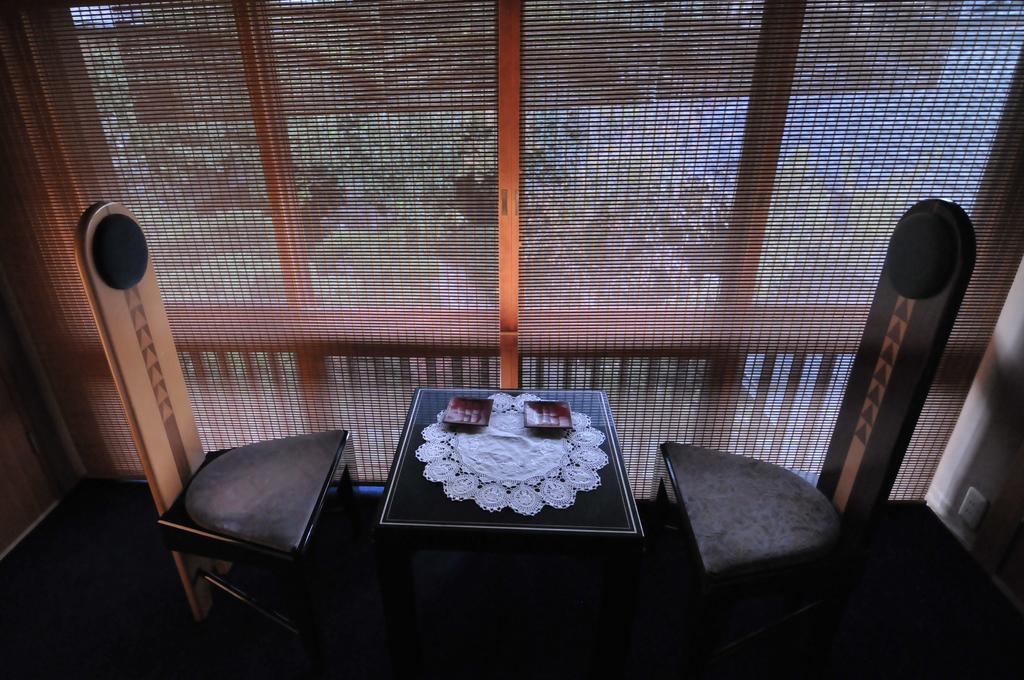Could you give a brief overview of what you see in this image? In this picture there is a table in the center of the image and there are chairs on the right and left side of the image, there is net in the center of the image. 